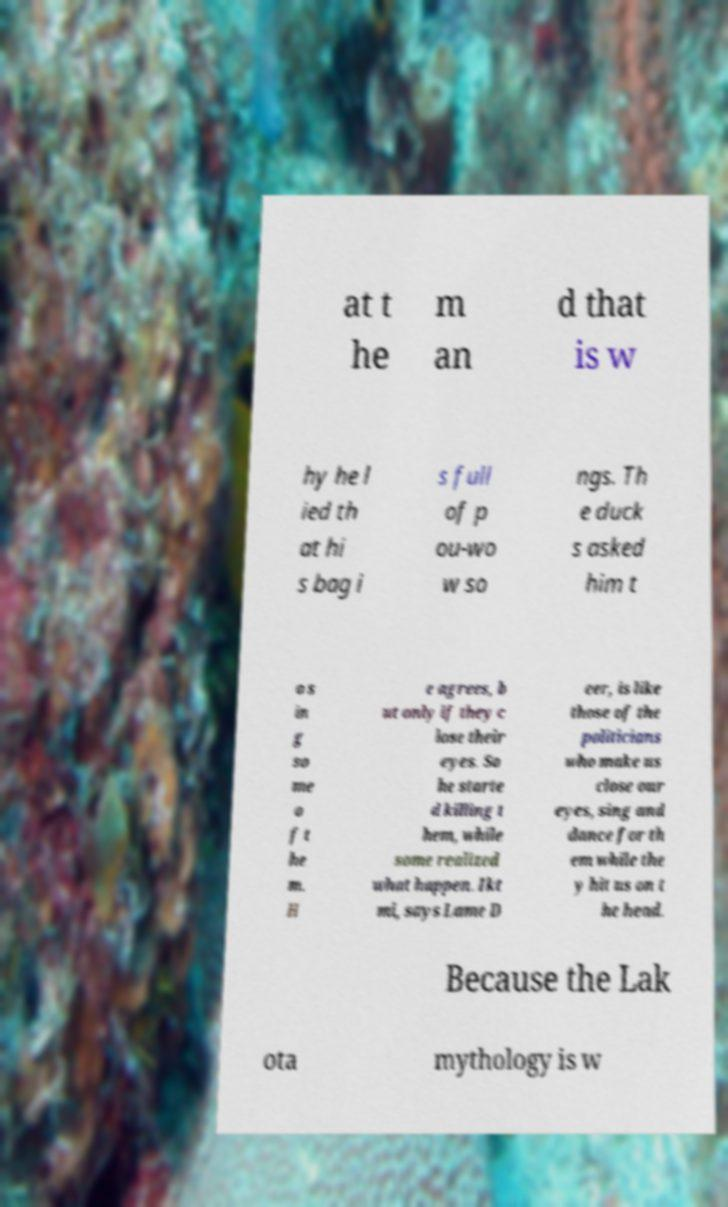Could you extract and type out the text from this image? at t he m an d that is w hy he l ied th at hi s bag i s full of p ou-wo w so ngs. Th e duck s asked him t o s in g so me o f t he m. H e agrees, b ut only if they c lose their eyes. So he starte d killing t hem, while some realized what happen. Ikt mi, says Lame D eer, is like those of the politicians who make us close our eyes, sing and dance for th em while the y hit us on t he head. Because the Lak ota mythology is w 